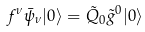<formula> <loc_0><loc_0><loc_500><loc_500>f ^ { \nu } \bar { \psi } _ { \nu } | 0 \rangle = \tilde { Q } _ { 0 } \tilde { g } ^ { 0 } | 0 \rangle</formula> 